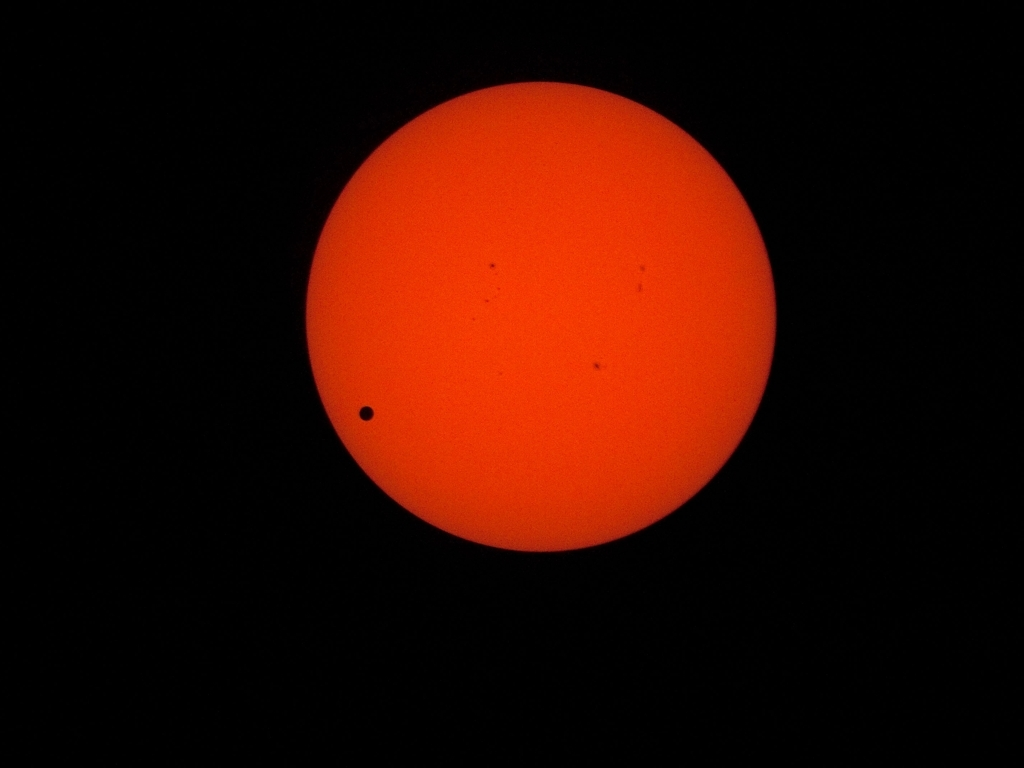What equipment or methods would likely have been used to capture this kind of image safely? To safely capture this type of image of the sun, specialized equipment is necessary. A telescope equipped with a solar filter to protect the camera sensor (and the photographer's eyes) from the intense sunlight is typically used. The filter permits only a fraction of the sun's light to pass through, allowing for a clear and detailed image of the sun's surface and any event, like a transit, without risking damage. It's also common to use a high-speed shutter and low ISO to minimize overexposure and glare for a sharp image. 